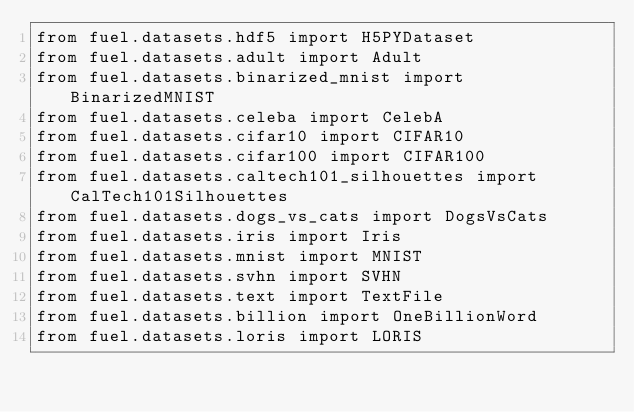<code> <loc_0><loc_0><loc_500><loc_500><_Python_>from fuel.datasets.hdf5 import H5PYDataset
from fuel.datasets.adult import Adult
from fuel.datasets.binarized_mnist import BinarizedMNIST
from fuel.datasets.celeba import CelebA
from fuel.datasets.cifar10 import CIFAR10
from fuel.datasets.cifar100 import CIFAR100
from fuel.datasets.caltech101_silhouettes import CalTech101Silhouettes
from fuel.datasets.dogs_vs_cats import DogsVsCats
from fuel.datasets.iris import Iris
from fuel.datasets.mnist import MNIST
from fuel.datasets.svhn import SVHN
from fuel.datasets.text import TextFile
from fuel.datasets.billion import OneBillionWord
from fuel.datasets.loris import LORIS
</code> 